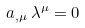Convert formula to latex. <formula><loc_0><loc_0><loc_500><loc_500>a _ { , \mu } \, \lambda ^ { \mu } = 0</formula> 